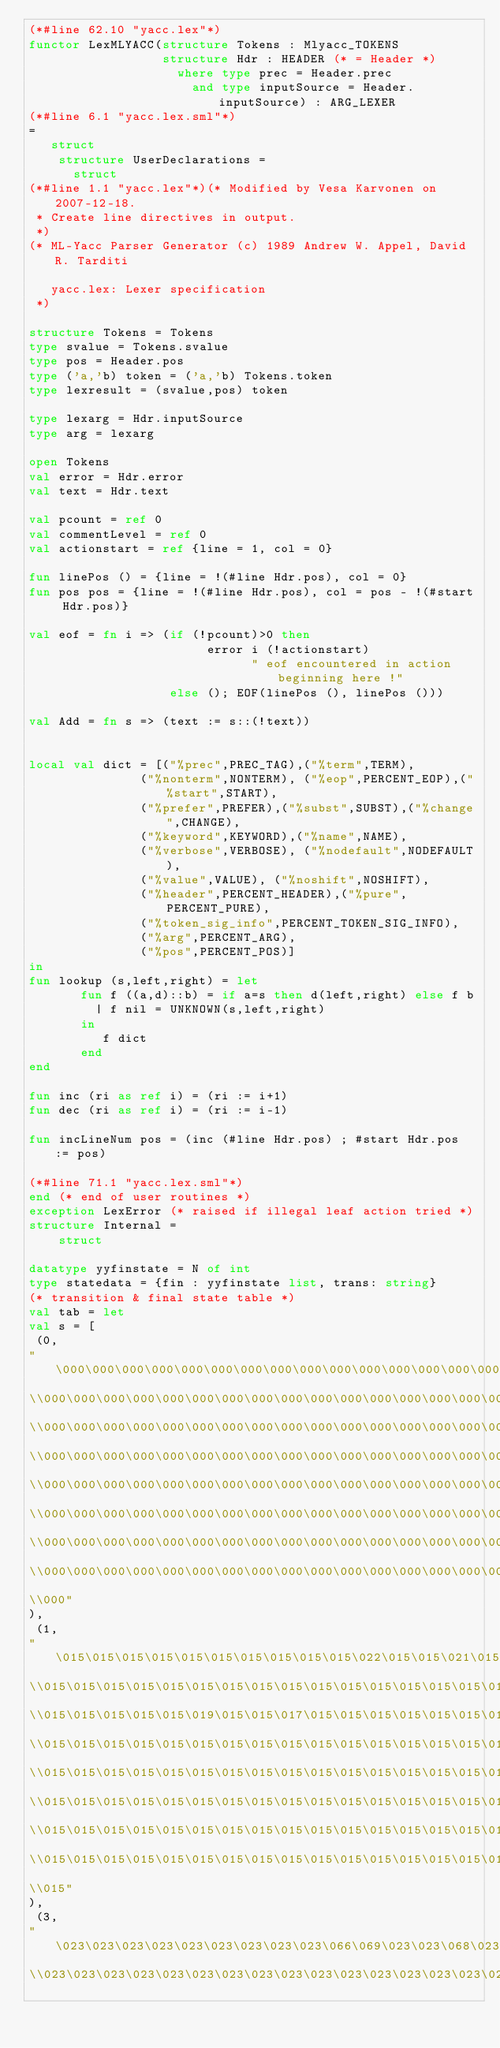Convert code to text. <code><loc_0><loc_0><loc_500><loc_500><_SML_>(*#line 62.10 "yacc.lex"*)
functor LexMLYACC(structure Tokens : Mlyacc_TOKENS
                  structure Hdr : HEADER (* = Header *)
                    where type prec = Header.prec
                      and type inputSource = Header.inputSource) : ARG_LEXER
(*#line 6.1 "yacc.lex.sml"*)
=
   struct
    structure UserDeclarations =
      struct
(*#line 1.1 "yacc.lex"*)(* Modified by Vesa Karvonen on 2007-12-18.
 * Create line directives in output.
 *)
(* ML-Yacc Parser Generator (c) 1989 Andrew W. Appel, David R. Tarditi

   yacc.lex: Lexer specification
 *)

structure Tokens = Tokens
type svalue = Tokens.svalue
type pos = Header.pos
type ('a,'b) token = ('a,'b) Tokens.token
type lexresult = (svalue,pos) token

type lexarg = Hdr.inputSource
type arg = lexarg

open Tokens
val error = Hdr.error
val text = Hdr.text

val pcount = ref 0
val commentLevel = ref 0
val actionstart = ref {line = 1, col = 0}

fun linePos () = {line = !(#line Hdr.pos), col = 0}
fun pos pos = {line = !(#line Hdr.pos), col = pos - !(#start Hdr.pos)}

val eof = fn i => (if (!pcount)>0 then
                        error i (!actionstart)
                              " eof encountered in action beginning here !"
                   else (); EOF(linePos (), linePos ()))

val Add = fn s => (text := s::(!text))


local val dict = [("%prec",PREC_TAG),("%term",TERM),
               ("%nonterm",NONTERM), ("%eop",PERCENT_EOP),("%start",START),
               ("%prefer",PREFER),("%subst",SUBST),("%change",CHANGE),
               ("%keyword",KEYWORD),("%name",NAME),
               ("%verbose",VERBOSE), ("%nodefault",NODEFAULT),
               ("%value",VALUE), ("%noshift",NOSHIFT),
               ("%header",PERCENT_HEADER),("%pure",PERCENT_PURE),
               ("%token_sig_info",PERCENT_TOKEN_SIG_INFO),
               ("%arg",PERCENT_ARG),
               ("%pos",PERCENT_POS)]
in
fun lookup (s,left,right) = let
       fun f ((a,d)::b) = if a=s then d(left,right) else f b
         | f nil = UNKNOWN(s,left,right)
       in
          f dict
       end
end

fun inc (ri as ref i) = (ri := i+1)
fun dec (ri as ref i) = (ri := i-1)

fun incLineNum pos = (inc (#line Hdr.pos) ; #start Hdr.pos := pos)

(*#line 71.1 "yacc.lex.sml"*)
end (* end of user routines *)
exception LexError (* raised if illegal leaf action tried *)
structure Internal =
	struct

datatype yyfinstate = N of int
type statedata = {fin : yyfinstate list, trans: string}
(* transition & final state table *)
val tab = let
val s = [ 
 (0, 
"\000\000\000\000\000\000\000\000\000\000\000\000\000\000\000\000\
\\000\000\000\000\000\000\000\000\000\000\000\000\000\000\000\000\
\\000\000\000\000\000\000\000\000\000\000\000\000\000\000\000\000\
\\000\000\000\000\000\000\000\000\000\000\000\000\000\000\000\000\
\\000\000\000\000\000\000\000\000\000\000\000\000\000\000\000\000\
\\000\000\000\000\000\000\000\000\000\000\000\000\000\000\000\000\
\\000\000\000\000\000\000\000\000\000\000\000\000\000\000\000\000\
\\000\000\000\000\000\000\000\000\000\000\000\000\000\000\000\000\
\\000"
),
 (1, 
"\015\015\015\015\015\015\015\015\015\015\022\015\015\021\015\015\
\\015\015\015\015\015\015\015\015\015\015\015\015\015\015\015\015\
\\015\015\015\015\015\019\015\015\017\015\015\015\015\015\015\015\
\\015\015\015\015\015\015\015\015\015\015\015\015\015\015\015\015\
\\015\015\015\015\015\015\015\015\015\015\015\015\015\015\015\015\
\\015\015\015\015\015\015\015\015\015\015\015\015\015\015\015\015\
\\015\015\015\015\015\015\015\015\015\015\015\015\015\015\015\015\
\\015\015\015\015\015\015\015\015\015\015\015\015\015\015\015\015\
\\015"
),
 (3, 
"\023\023\023\023\023\023\023\023\023\066\069\023\023\068\023\023\
\\023\023\023\023\023\023\023\023\023\023\023\023\023\023\023\023\</code> 